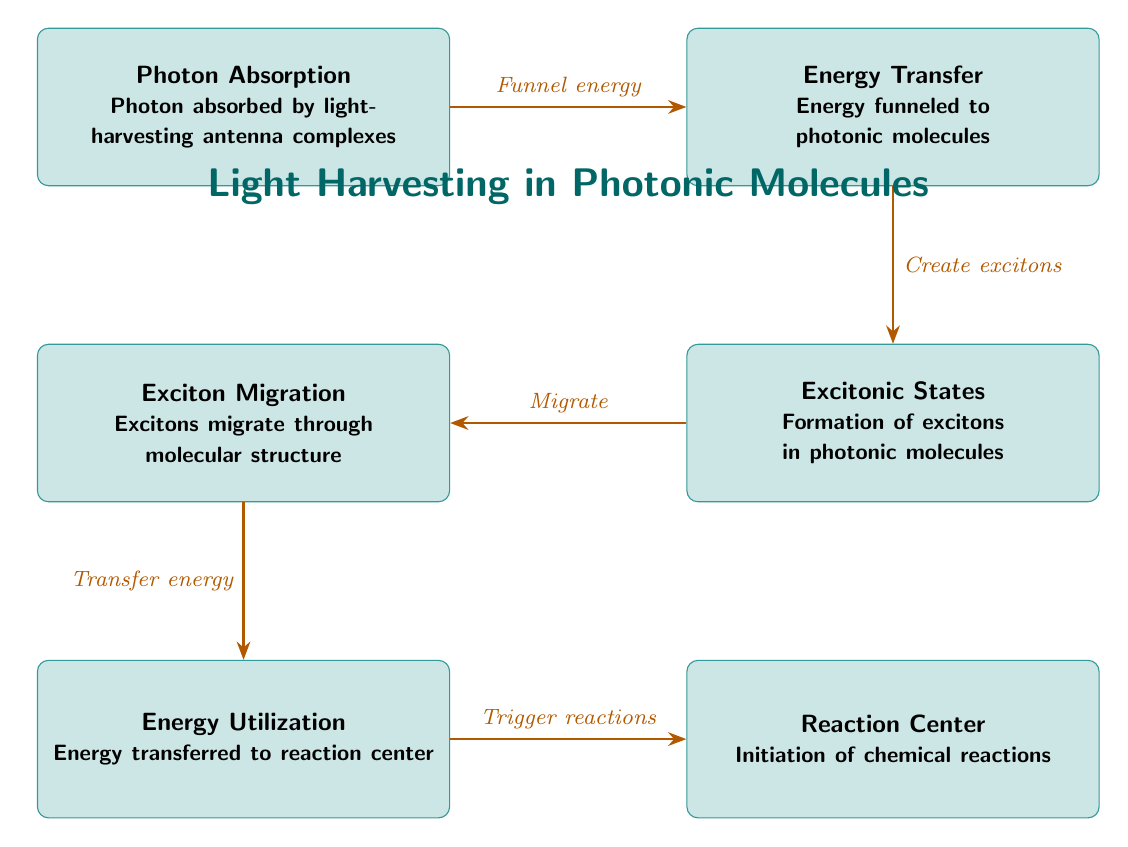What is the first process in the diagram? The diagram lists the processes in a sequence, starting with "Photon Absorption" at the top.
Answer: Photon Absorption How many processes are represented in the diagram? The diagram includes six distinct processes connected in a flow, from "Photon Absorption" to "Reaction Center."
Answer: 6 What is the function of the "Exciton Migration" process? "Exciton Migration" refers to the step where excitons move through the molecular structure, as indicated by the description below the process in the diagram.
Answer: Excitons migrate through molecular structure Which process follows "Energy Transfer"? The arrow from "Energy Transfer" points directly to "Excitonic States," indicating that it is the next step in the sequence.
Answer: Excitonic States What does the "Reaction Center" process trigger? The "Reaction Center" is described as initiating chemical reactions, indicating its role within the larger light harvesting system.
Answer: Initiation of chemical reactions What is transferred during the "Exciton Migration"? The description of "Exciton Migration" states that it involves the transfer of energy, evidencing its purpose in the energy flow.
Answer: Energy What is the relationship between "Photon Absorption" and "Energy Transfer"? The diagram indicates that "Photon Absorption" funnels energy to "Energy Transfer," suggesting a direct progression from one process to the next.
Answer: Funnel energy Explain the overall direction of energy flow in this food chain. The diagram illustrates a clear flow of energy starting from "Photon Absorption," which moves through "Energy Transfer," "Excitonic States," "Exciton Migration," and culminates at the "Reaction Center," showing a chain of energy transformation.
Answer: From Photon Absorption to Reaction Center 